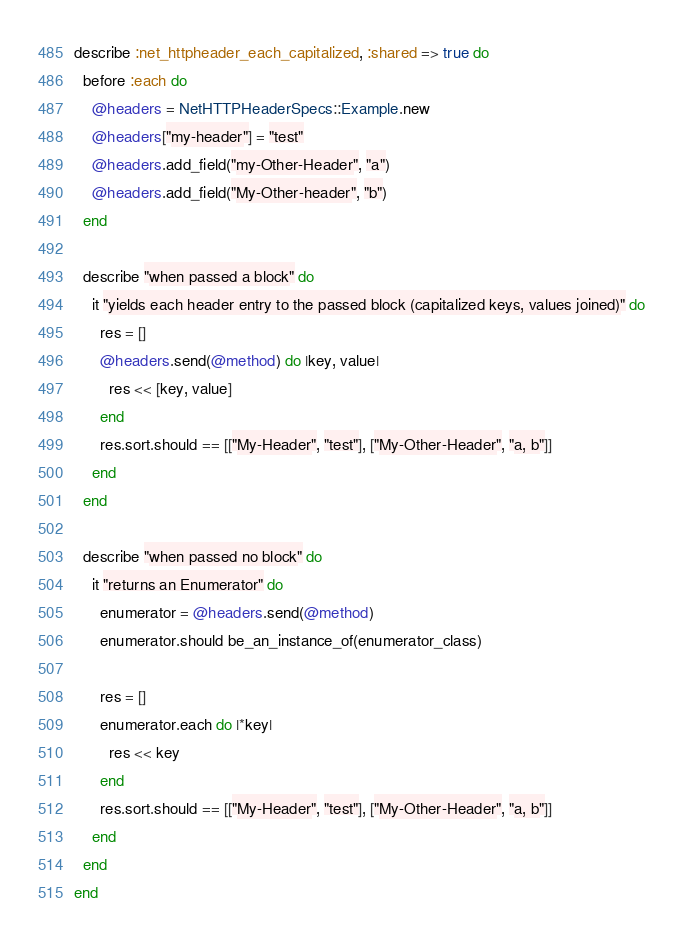Convert code to text. <code><loc_0><loc_0><loc_500><loc_500><_Ruby_>describe :net_httpheader_each_capitalized, :shared => true do
  before :each do
    @headers = NetHTTPHeaderSpecs::Example.new
    @headers["my-header"] = "test"
    @headers.add_field("my-Other-Header", "a")
    @headers.add_field("My-Other-header", "b")
  end

  describe "when passed a block" do
    it "yields each header entry to the passed block (capitalized keys, values joined)" do
      res = []
      @headers.send(@method) do |key, value|
        res << [key, value]
      end
      res.sort.should == [["My-Header", "test"], ["My-Other-Header", "a, b"]]
    end
  end

  describe "when passed no block" do
    it "returns an Enumerator" do
      enumerator = @headers.send(@method)
      enumerator.should be_an_instance_of(enumerator_class)

      res = []
      enumerator.each do |*key|
        res << key
      end
      res.sort.should == [["My-Header", "test"], ["My-Other-Header", "a, b"]]
    end
  end
end
</code> 